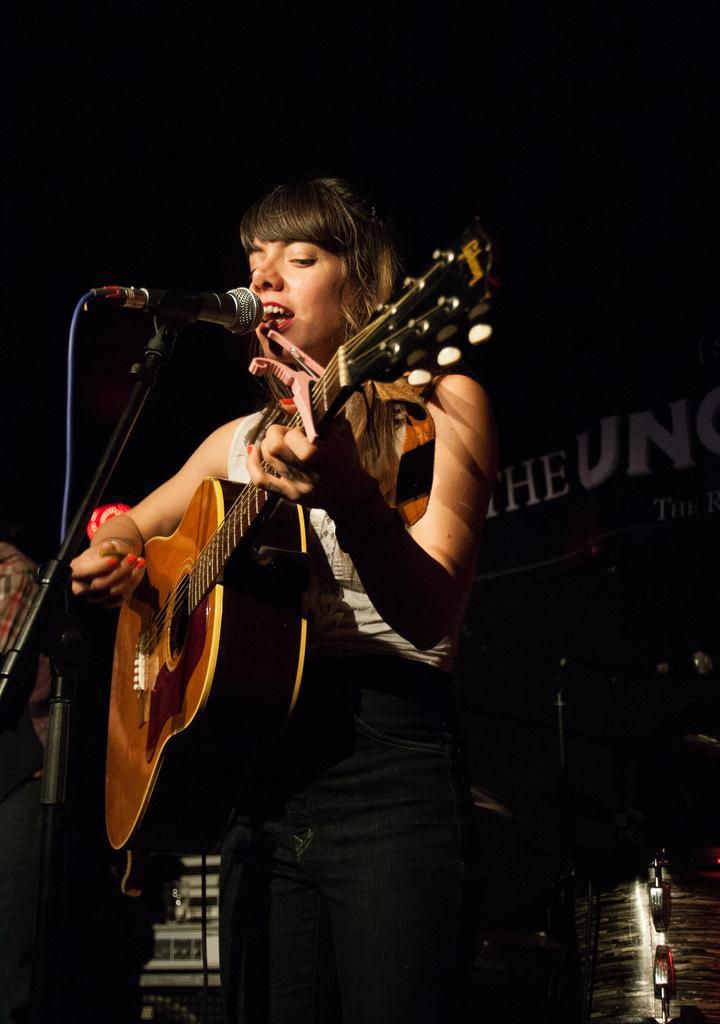In one or two sentences, can you explain what this image depicts? In this picture of woman standing, singing and there's a microphone and playing a guitar. 